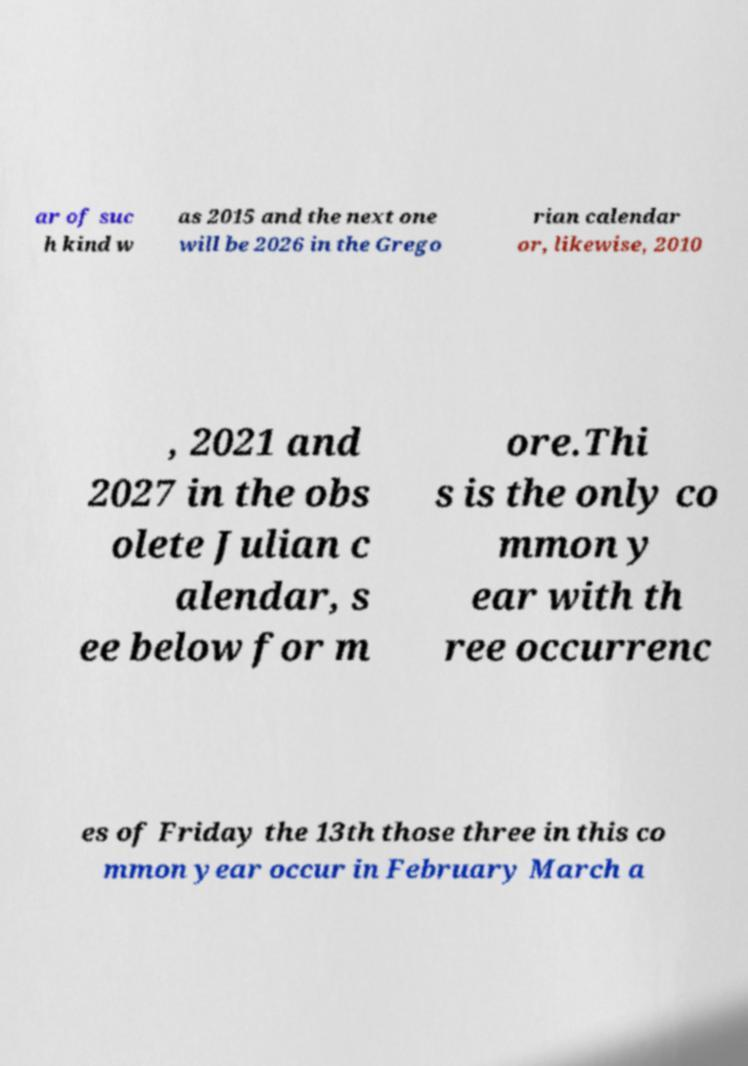There's text embedded in this image that I need extracted. Can you transcribe it verbatim? ar of suc h kind w as 2015 and the next one will be 2026 in the Grego rian calendar or, likewise, 2010 , 2021 and 2027 in the obs olete Julian c alendar, s ee below for m ore.Thi s is the only co mmon y ear with th ree occurrenc es of Friday the 13th those three in this co mmon year occur in February March a 